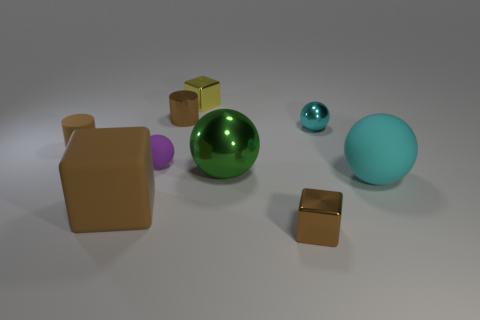Subtract 1 spheres. How many spheres are left? 3 Subtract all green balls. How many balls are left? 3 Subtract all yellow balls. Subtract all gray cylinders. How many balls are left? 4 Subtract all spheres. How many objects are left? 5 Add 8 tiny purple metal blocks. How many tiny purple metal blocks exist? 8 Subtract 2 brown cylinders. How many objects are left? 7 Subtract all small yellow shiny objects. Subtract all tiny shiny cubes. How many objects are left? 6 Add 6 tiny purple things. How many tiny purple things are left? 7 